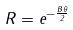Convert formula to latex. <formula><loc_0><loc_0><loc_500><loc_500>R = e ^ { - \frac { B \theta } { 2 } }</formula> 